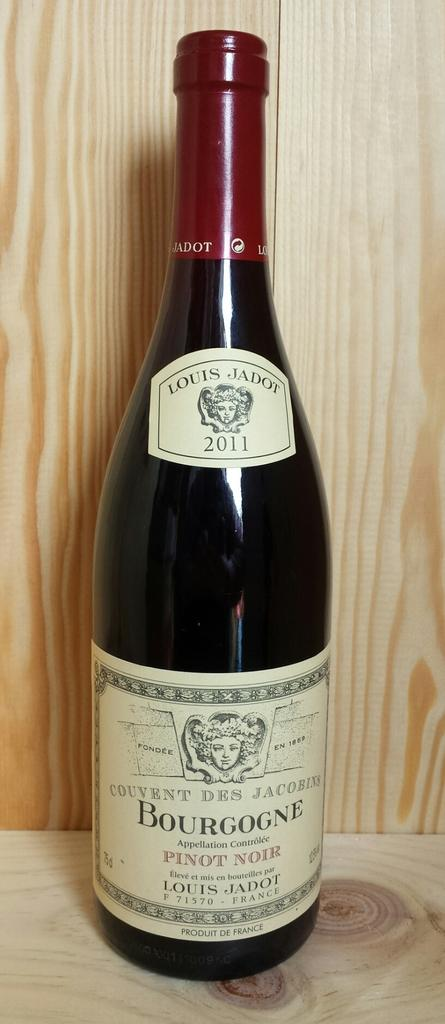<image>
Offer a succinct explanation of the picture presented. Bottle of Bourgogne Pinot Noir on a wooden shelf. 